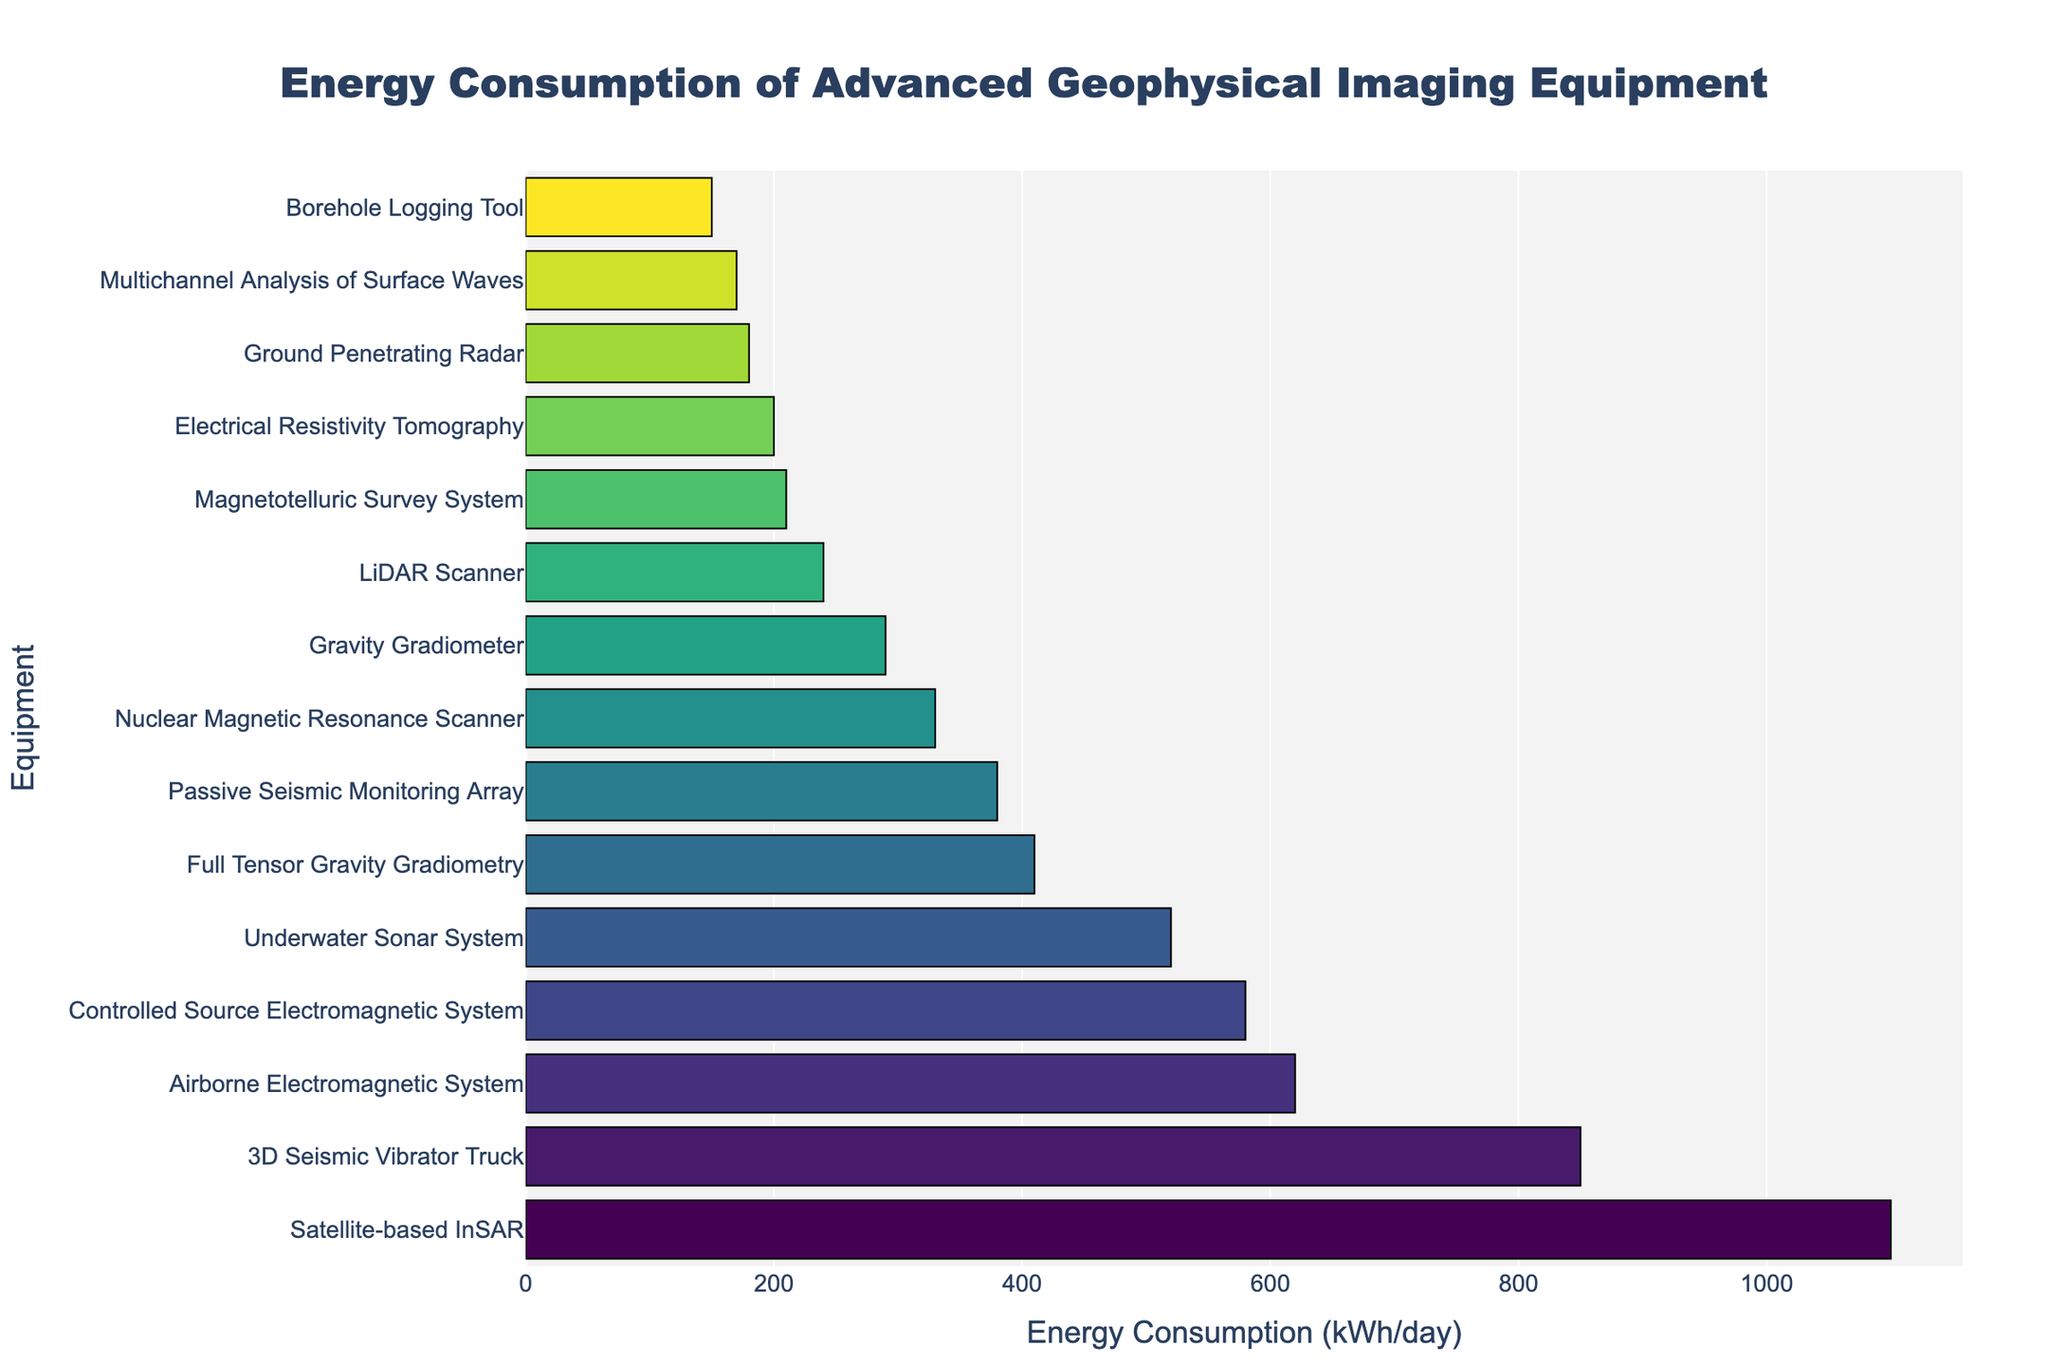What's the equipment with the highest energy consumption? The equipment with the highest energy consumption is positioned at the top of the sorted bar chart. Refer to the figure to identify the top bar.
Answer: Satellite-based InSAR What is the difference in energy consumption between the 3D Seismic Vibrator Truck and Ground Penetrating Radar? Find the energy consumption values for both pieces of equipment from the chart: 850 kWh/day for the 3D Seismic Vibrator Truck and 180 kWh/day for the Ground Penetrating Radar. Subtract the latter from the former (850 - 180).
Answer: 670 kWh/day Which equipment consumes less energy than the Airborne Electromagnetic System but more than the Gravity Gradiometer? Identify the energy consumption values of the Airborne Electromagnetic System (620 kWh/day) and the Gravity Gradiometer (290 kWh/day). Look for equipment in the chart that has energy consumption between these values.
Answer: Underwater Sonar System What is the average energy consumption of the Borehole Logging Tool, Electrical Resistivity Tomography, and LiDAR Scanner? Add up the energy consumption for these three pieces of equipment (150 + 200 + 240) and then divide by 3.
Answer: 196.67 kWh/day Which equipment has similar energy consumption to Nuclear Magnetic Resonance Scanner? Identify the energy consumption of Nuclear Magnetic Resonance Scanner (330 kWh/day). Look for bars close to this value in the chart.
Answer: Passive Seismic Monitoring Array What is the total energy consumption for equipment that uses more than 500 kWh/day? Identify all equipment with energy consumption above 500 kWh/day from the chart and sum their energy consumptions: 3D Seismic Vibrator Truck (850) + Airborne Electromagnetic System (620) + Satellite-based InSAR (1100) + Underwater Sonar System (520).
Answer: 3090 kWh/day Is the energy consumption of the Magnetotelluric Survey System greater or less than the Electrical Resistivity Tomography? Locate the energy consumption values for both Magnetotelluric Survey System (210 kWh/day) and Electrical Resistivity Tomography (200 kWh/day) on the chart and compare them.
Answer: Greater What is the median energy consumption of all listed equipment? Arrange the energy consumption values in ascending order, then find the middle value. If there is an even number of values, average the two middle ones. The ordered values are: 110, 150, 170, 180, 200, 210, 240, 290, 330, 380, 410, 520, 580, 620, 850, 1100. The median is the average of the 8th and 9th values, (290 + 330)/2.
Answer: 310 kWh/day 